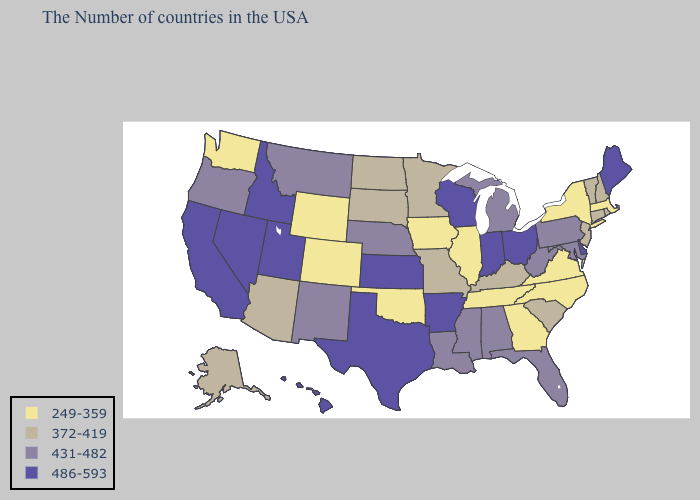Does the first symbol in the legend represent the smallest category?
Write a very short answer. Yes. Does the map have missing data?
Keep it brief. No. Does Arkansas have the same value as Idaho?
Short answer required. Yes. Name the states that have a value in the range 249-359?
Concise answer only. Massachusetts, New York, Virginia, North Carolina, Georgia, Tennessee, Illinois, Iowa, Oklahoma, Wyoming, Colorado, Washington. Name the states that have a value in the range 372-419?
Write a very short answer. Rhode Island, New Hampshire, Vermont, Connecticut, New Jersey, South Carolina, Kentucky, Missouri, Minnesota, South Dakota, North Dakota, Arizona, Alaska. Among the states that border Massachusetts , does New York have the lowest value?
Short answer required. Yes. Which states hav the highest value in the South?
Write a very short answer. Delaware, Arkansas, Texas. What is the value of Nevada?
Write a very short answer. 486-593. What is the value of Maryland?
Concise answer only. 431-482. Which states have the lowest value in the MidWest?
Concise answer only. Illinois, Iowa. Among the states that border Georgia , does Alabama have the lowest value?
Concise answer only. No. Which states have the highest value in the USA?
Be succinct. Maine, Delaware, Ohio, Indiana, Wisconsin, Arkansas, Kansas, Texas, Utah, Idaho, Nevada, California, Hawaii. What is the lowest value in states that border Oklahoma?
Keep it brief. 249-359. Which states hav the highest value in the MidWest?
Keep it brief. Ohio, Indiana, Wisconsin, Kansas. Does Louisiana have a higher value than Alabama?
Quick response, please. No. 